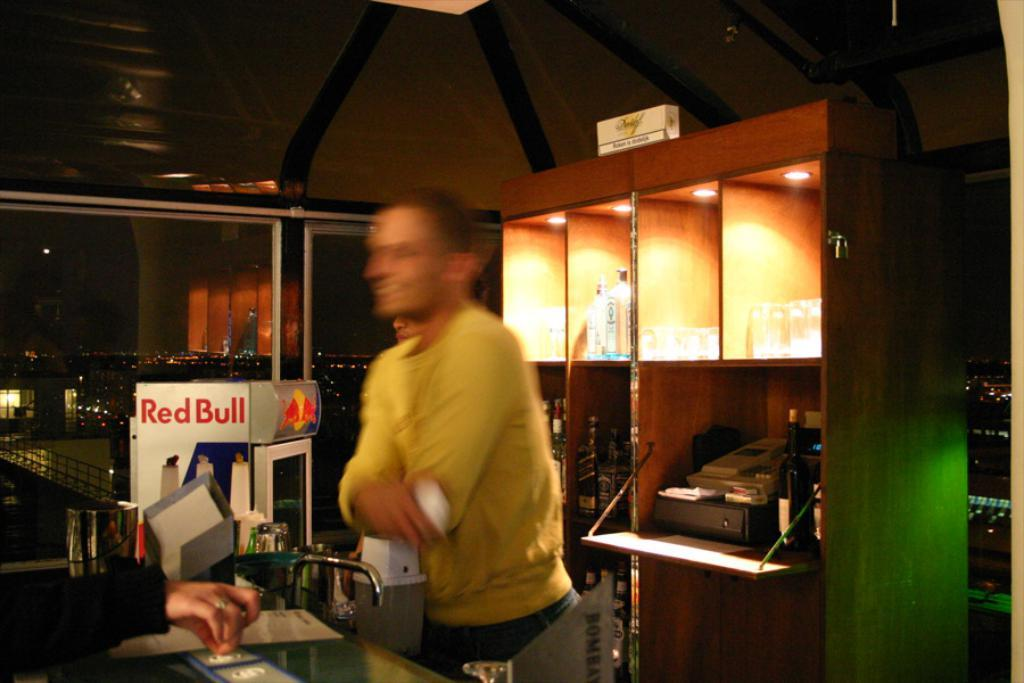<image>
Share a concise interpretation of the image provided. a blurry take of a man standing behind a bar near a machine with the red bull logo on its front. 